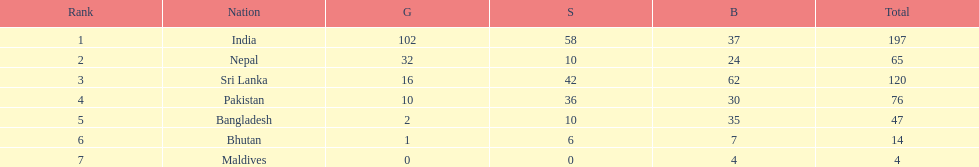What are all the countries listed in the table? India, Nepal, Sri Lanka, Pakistan, Bangladesh, Bhutan, Maldives. Which of these is not india? Nepal, Sri Lanka, Pakistan, Bangladesh, Bhutan, Maldives. Of these, which is first? Nepal. 